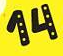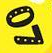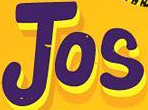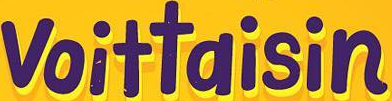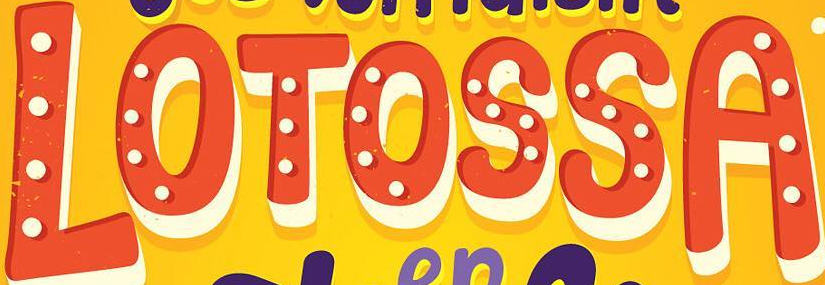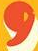What text appears in these images from left to right, separated by a semicolon? 14; 07; Jos; voittaisin; LOTOSSA; , 